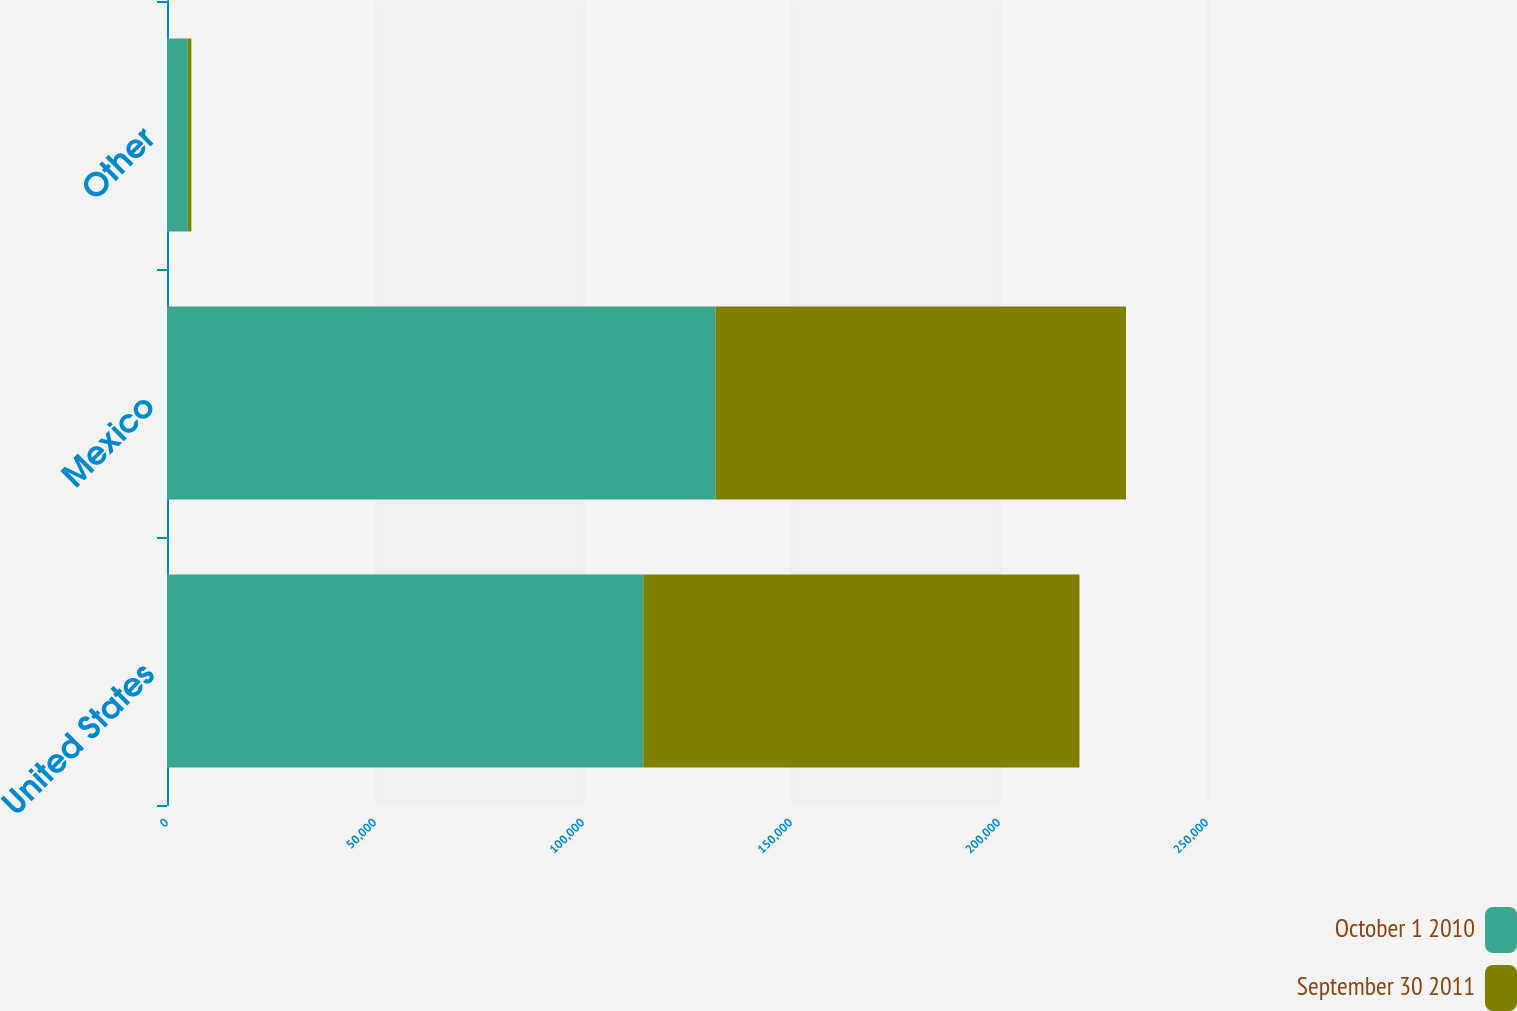Convert chart. <chart><loc_0><loc_0><loc_500><loc_500><stacked_bar_chart><ecel><fcel>United States<fcel>Mexico<fcel>Other<nl><fcel>October 1 2010<fcel>114492<fcel>131862<fcel>5011<nl><fcel>September 30 2011<fcel>104846<fcel>98667<fcel>850<nl></chart> 